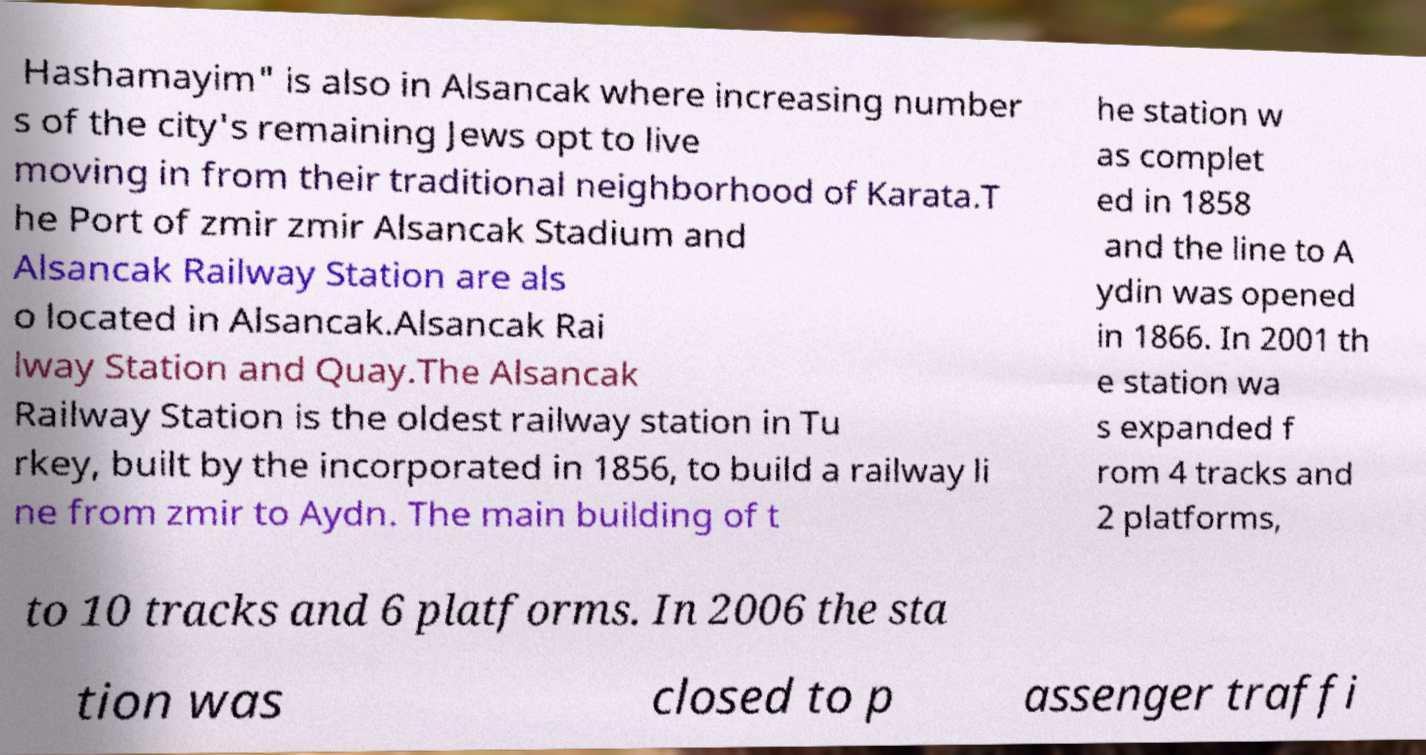Can you read and provide the text displayed in the image?This photo seems to have some interesting text. Can you extract and type it out for me? Hashamayim" is also in Alsancak where increasing number s of the city's remaining Jews opt to live moving in from their traditional neighborhood of Karata.T he Port of zmir zmir Alsancak Stadium and Alsancak Railway Station are als o located in Alsancak.Alsancak Rai lway Station and Quay.The Alsancak Railway Station is the oldest railway station in Tu rkey, built by the incorporated in 1856, to build a railway li ne from zmir to Aydn. The main building of t he station w as complet ed in 1858 and the line to A ydin was opened in 1866. In 2001 th e station wa s expanded f rom 4 tracks and 2 platforms, to 10 tracks and 6 platforms. In 2006 the sta tion was closed to p assenger traffi 